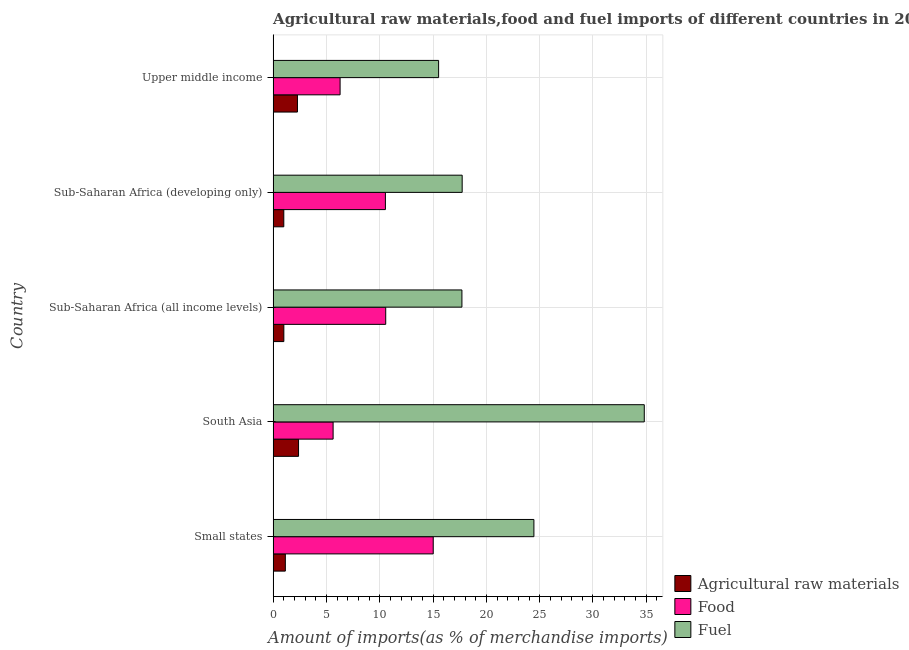Are the number of bars on each tick of the Y-axis equal?
Provide a succinct answer. Yes. How many bars are there on the 3rd tick from the bottom?
Provide a short and direct response. 3. What is the label of the 3rd group of bars from the top?
Offer a very short reply. Sub-Saharan Africa (all income levels). What is the percentage of fuel imports in Sub-Saharan Africa (developing only)?
Your response must be concise. 17.73. Across all countries, what is the maximum percentage of food imports?
Keep it short and to the point. 15.01. Across all countries, what is the minimum percentage of food imports?
Your response must be concise. 5.63. In which country was the percentage of raw materials imports minimum?
Provide a short and direct response. Sub-Saharan Africa (developing only). What is the total percentage of food imports in the graph?
Offer a terse response. 48.01. What is the difference between the percentage of food imports in South Asia and that in Sub-Saharan Africa (all income levels)?
Provide a succinct answer. -4.93. What is the difference between the percentage of fuel imports in Sub-Saharan Africa (developing only) and the percentage of raw materials imports in Upper middle income?
Make the answer very short. 15.45. What is the average percentage of raw materials imports per country?
Provide a short and direct response. 1.56. What is the difference between the percentage of food imports and percentage of raw materials imports in Sub-Saharan Africa (developing only)?
Ensure brevity in your answer.  9.53. In how many countries, is the percentage of fuel imports greater than 12 %?
Provide a succinct answer. 5. What is the ratio of the percentage of raw materials imports in Small states to that in Upper middle income?
Offer a very short reply. 0.5. Is the percentage of fuel imports in Sub-Saharan Africa (all income levels) less than that in Upper middle income?
Ensure brevity in your answer.  No. Is the difference between the percentage of food imports in Sub-Saharan Africa (developing only) and Upper middle income greater than the difference between the percentage of raw materials imports in Sub-Saharan Africa (developing only) and Upper middle income?
Make the answer very short. Yes. What is the difference between the highest and the second highest percentage of raw materials imports?
Offer a terse response. 0.1. What is the difference between the highest and the lowest percentage of fuel imports?
Your answer should be very brief. 19.29. In how many countries, is the percentage of raw materials imports greater than the average percentage of raw materials imports taken over all countries?
Keep it short and to the point. 2. What does the 3rd bar from the top in South Asia represents?
Give a very brief answer. Agricultural raw materials. What does the 1st bar from the bottom in South Asia represents?
Give a very brief answer. Agricultural raw materials. Is it the case that in every country, the sum of the percentage of raw materials imports and percentage of food imports is greater than the percentage of fuel imports?
Ensure brevity in your answer.  No. Are all the bars in the graph horizontal?
Give a very brief answer. Yes. What is the difference between two consecutive major ticks on the X-axis?
Offer a very short reply. 5. Are the values on the major ticks of X-axis written in scientific E-notation?
Your answer should be compact. No. Where does the legend appear in the graph?
Ensure brevity in your answer.  Bottom right. How many legend labels are there?
Offer a very short reply. 3. What is the title of the graph?
Your answer should be compact. Agricultural raw materials,food and fuel imports of different countries in 2008. What is the label or title of the X-axis?
Your answer should be very brief. Amount of imports(as % of merchandise imports). What is the label or title of the Y-axis?
Provide a short and direct response. Country. What is the Amount of imports(as % of merchandise imports) of Agricultural raw materials in Small states?
Your response must be concise. 1.15. What is the Amount of imports(as % of merchandise imports) of Food in Small states?
Offer a very short reply. 15.01. What is the Amount of imports(as % of merchandise imports) in Fuel in Small states?
Offer a terse response. 24.46. What is the Amount of imports(as % of merchandise imports) of Agricultural raw materials in South Asia?
Offer a terse response. 2.38. What is the Amount of imports(as % of merchandise imports) of Food in South Asia?
Offer a terse response. 5.63. What is the Amount of imports(as % of merchandise imports) in Fuel in South Asia?
Your response must be concise. 34.81. What is the Amount of imports(as % of merchandise imports) in Agricultural raw materials in Sub-Saharan Africa (all income levels)?
Ensure brevity in your answer.  1.01. What is the Amount of imports(as % of merchandise imports) in Food in Sub-Saharan Africa (all income levels)?
Give a very brief answer. 10.56. What is the Amount of imports(as % of merchandise imports) of Fuel in Sub-Saharan Africa (all income levels)?
Your answer should be compact. 17.71. What is the Amount of imports(as % of merchandise imports) in Agricultural raw materials in Sub-Saharan Africa (developing only)?
Provide a short and direct response. 1. What is the Amount of imports(as % of merchandise imports) of Food in Sub-Saharan Africa (developing only)?
Your answer should be compact. 10.53. What is the Amount of imports(as % of merchandise imports) in Fuel in Sub-Saharan Africa (developing only)?
Offer a terse response. 17.73. What is the Amount of imports(as % of merchandise imports) of Agricultural raw materials in Upper middle income?
Your response must be concise. 2.28. What is the Amount of imports(as % of merchandise imports) in Food in Upper middle income?
Ensure brevity in your answer.  6.28. What is the Amount of imports(as % of merchandise imports) of Fuel in Upper middle income?
Provide a succinct answer. 15.52. Across all countries, what is the maximum Amount of imports(as % of merchandise imports) of Agricultural raw materials?
Your response must be concise. 2.38. Across all countries, what is the maximum Amount of imports(as % of merchandise imports) of Food?
Keep it short and to the point. 15.01. Across all countries, what is the maximum Amount of imports(as % of merchandise imports) in Fuel?
Your answer should be very brief. 34.81. Across all countries, what is the minimum Amount of imports(as % of merchandise imports) of Agricultural raw materials?
Offer a very short reply. 1. Across all countries, what is the minimum Amount of imports(as % of merchandise imports) in Food?
Your response must be concise. 5.63. Across all countries, what is the minimum Amount of imports(as % of merchandise imports) of Fuel?
Your response must be concise. 15.52. What is the total Amount of imports(as % of merchandise imports) in Agricultural raw materials in the graph?
Your answer should be very brief. 7.82. What is the total Amount of imports(as % of merchandise imports) of Food in the graph?
Your answer should be compact. 48.01. What is the total Amount of imports(as % of merchandise imports) of Fuel in the graph?
Offer a very short reply. 110.23. What is the difference between the Amount of imports(as % of merchandise imports) in Agricultural raw materials in Small states and that in South Asia?
Ensure brevity in your answer.  -1.24. What is the difference between the Amount of imports(as % of merchandise imports) of Food in Small states and that in South Asia?
Make the answer very short. 9.39. What is the difference between the Amount of imports(as % of merchandise imports) in Fuel in Small states and that in South Asia?
Your answer should be very brief. -10.35. What is the difference between the Amount of imports(as % of merchandise imports) in Agricultural raw materials in Small states and that in Sub-Saharan Africa (all income levels)?
Give a very brief answer. 0.14. What is the difference between the Amount of imports(as % of merchandise imports) in Food in Small states and that in Sub-Saharan Africa (all income levels)?
Your answer should be very brief. 4.46. What is the difference between the Amount of imports(as % of merchandise imports) of Fuel in Small states and that in Sub-Saharan Africa (all income levels)?
Give a very brief answer. 6.75. What is the difference between the Amount of imports(as % of merchandise imports) in Agricultural raw materials in Small states and that in Sub-Saharan Africa (developing only)?
Ensure brevity in your answer.  0.14. What is the difference between the Amount of imports(as % of merchandise imports) of Food in Small states and that in Sub-Saharan Africa (developing only)?
Offer a very short reply. 4.48. What is the difference between the Amount of imports(as % of merchandise imports) of Fuel in Small states and that in Sub-Saharan Africa (developing only)?
Your answer should be compact. 6.73. What is the difference between the Amount of imports(as % of merchandise imports) in Agricultural raw materials in Small states and that in Upper middle income?
Give a very brief answer. -1.14. What is the difference between the Amount of imports(as % of merchandise imports) in Food in Small states and that in Upper middle income?
Provide a short and direct response. 8.73. What is the difference between the Amount of imports(as % of merchandise imports) in Fuel in Small states and that in Upper middle income?
Ensure brevity in your answer.  8.94. What is the difference between the Amount of imports(as % of merchandise imports) of Agricultural raw materials in South Asia and that in Sub-Saharan Africa (all income levels)?
Ensure brevity in your answer.  1.38. What is the difference between the Amount of imports(as % of merchandise imports) in Food in South Asia and that in Sub-Saharan Africa (all income levels)?
Offer a very short reply. -4.93. What is the difference between the Amount of imports(as % of merchandise imports) of Fuel in South Asia and that in Sub-Saharan Africa (all income levels)?
Make the answer very short. 17.1. What is the difference between the Amount of imports(as % of merchandise imports) in Agricultural raw materials in South Asia and that in Sub-Saharan Africa (developing only)?
Your answer should be very brief. 1.38. What is the difference between the Amount of imports(as % of merchandise imports) in Food in South Asia and that in Sub-Saharan Africa (developing only)?
Your answer should be compact. -4.9. What is the difference between the Amount of imports(as % of merchandise imports) of Fuel in South Asia and that in Sub-Saharan Africa (developing only)?
Give a very brief answer. 17.08. What is the difference between the Amount of imports(as % of merchandise imports) of Agricultural raw materials in South Asia and that in Upper middle income?
Provide a short and direct response. 0.1. What is the difference between the Amount of imports(as % of merchandise imports) in Food in South Asia and that in Upper middle income?
Your response must be concise. -0.65. What is the difference between the Amount of imports(as % of merchandise imports) in Fuel in South Asia and that in Upper middle income?
Make the answer very short. 19.29. What is the difference between the Amount of imports(as % of merchandise imports) of Agricultural raw materials in Sub-Saharan Africa (all income levels) and that in Sub-Saharan Africa (developing only)?
Your answer should be compact. 0. What is the difference between the Amount of imports(as % of merchandise imports) in Food in Sub-Saharan Africa (all income levels) and that in Sub-Saharan Africa (developing only)?
Your answer should be compact. 0.03. What is the difference between the Amount of imports(as % of merchandise imports) in Fuel in Sub-Saharan Africa (all income levels) and that in Sub-Saharan Africa (developing only)?
Give a very brief answer. -0.02. What is the difference between the Amount of imports(as % of merchandise imports) of Agricultural raw materials in Sub-Saharan Africa (all income levels) and that in Upper middle income?
Your response must be concise. -1.28. What is the difference between the Amount of imports(as % of merchandise imports) in Food in Sub-Saharan Africa (all income levels) and that in Upper middle income?
Your answer should be compact. 4.28. What is the difference between the Amount of imports(as % of merchandise imports) in Fuel in Sub-Saharan Africa (all income levels) and that in Upper middle income?
Keep it short and to the point. 2.19. What is the difference between the Amount of imports(as % of merchandise imports) in Agricultural raw materials in Sub-Saharan Africa (developing only) and that in Upper middle income?
Provide a short and direct response. -1.28. What is the difference between the Amount of imports(as % of merchandise imports) of Food in Sub-Saharan Africa (developing only) and that in Upper middle income?
Offer a very short reply. 4.25. What is the difference between the Amount of imports(as % of merchandise imports) in Fuel in Sub-Saharan Africa (developing only) and that in Upper middle income?
Offer a very short reply. 2.21. What is the difference between the Amount of imports(as % of merchandise imports) of Agricultural raw materials in Small states and the Amount of imports(as % of merchandise imports) of Food in South Asia?
Your response must be concise. -4.48. What is the difference between the Amount of imports(as % of merchandise imports) in Agricultural raw materials in Small states and the Amount of imports(as % of merchandise imports) in Fuel in South Asia?
Give a very brief answer. -33.66. What is the difference between the Amount of imports(as % of merchandise imports) of Food in Small states and the Amount of imports(as % of merchandise imports) of Fuel in South Asia?
Give a very brief answer. -19.8. What is the difference between the Amount of imports(as % of merchandise imports) in Agricultural raw materials in Small states and the Amount of imports(as % of merchandise imports) in Food in Sub-Saharan Africa (all income levels)?
Make the answer very short. -9.41. What is the difference between the Amount of imports(as % of merchandise imports) of Agricultural raw materials in Small states and the Amount of imports(as % of merchandise imports) of Fuel in Sub-Saharan Africa (all income levels)?
Make the answer very short. -16.56. What is the difference between the Amount of imports(as % of merchandise imports) in Food in Small states and the Amount of imports(as % of merchandise imports) in Fuel in Sub-Saharan Africa (all income levels)?
Provide a short and direct response. -2.69. What is the difference between the Amount of imports(as % of merchandise imports) of Agricultural raw materials in Small states and the Amount of imports(as % of merchandise imports) of Food in Sub-Saharan Africa (developing only)?
Give a very brief answer. -9.39. What is the difference between the Amount of imports(as % of merchandise imports) in Agricultural raw materials in Small states and the Amount of imports(as % of merchandise imports) in Fuel in Sub-Saharan Africa (developing only)?
Ensure brevity in your answer.  -16.59. What is the difference between the Amount of imports(as % of merchandise imports) in Food in Small states and the Amount of imports(as % of merchandise imports) in Fuel in Sub-Saharan Africa (developing only)?
Your response must be concise. -2.72. What is the difference between the Amount of imports(as % of merchandise imports) in Agricultural raw materials in Small states and the Amount of imports(as % of merchandise imports) in Food in Upper middle income?
Your answer should be very brief. -5.14. What is the difference between the Amount of imports(as % of merchandise imports) in Agricultural raw materials in Small states and the Amount of imports(as % of merchandise imports) in Fuel in Upper middle income?
Your response must be concise. -14.37. What is the difference between the Amount of imports(as % of merchandise imports) in Food in Small states and the Amount of imports(as % of merchandise imports) in Fuel in Upper middle income?
Your answer should be compact. -0.51. What is the difference between the Amount of imports(as % of merchandise imports) in Agricultural raw materials in South Asia and the Amount of imports(as % of merchandise imports) in Food in Sub-Saharan Africa (all income levels)?
Keep it short and to the point. -8.18. What is the difference between the Amount of imports(as % of merchandise imports) of Agricultural raw materials in South Asia and the Amount of imports(as % of merchandise imports) of Fuel in Sub-Saharan Africa (all income levels)?
Ensure brevity in your answer.  -15.32. What is the difference between the Amount of imports(as % of merchandise imports) of Food in South Asia and the Amount of imports(as % of merchandise imports) of Fuel in Sub-Saharan Africa (all income levels)?
Ensure brevity in your answer.  -12.08. What is the difference between the Amount of imports(as % of merchandise imports) of Agricultural raw materials in South Asia and the Amount of imports(as % of merchandise imports) of Food in Sub-Saharan Africa (developing only)?
Ensure brevity in your answer.  -8.15. What is the difference between the Amount of imports(as % of merchandise imports) in Agricultural raw materials in South Asia and the Amount of imports(as % of merchandise imports) in Fuel in Sub-Saharan Africa (developing only)?
Ensure brevity in your answer.  -15.35. What is the difference between the Amount of imports(as % of merchandise imports) of Food in South Asia and the Amount of imports(as % of merchandise imports) of Fuel in Sub-Saharan Africa (developing only)?
Offer a very short reply. -12.1. What is the difference between the Amount of imports(as % of merchandise imports) of Agricultural raw materials in South Asia and the Amount of imports(as % of merchandise imports) of Food in Upper middle income?
Ensure brevity in your answer.  -3.9. What is the difference between the Amount of imports(as % of merchandise imports) of Agricultural raw materials in South Asia and the Amount of imports(as % of merchandise imports) of Fuel in Upper middle income?
Your answer should be very brief. -13.14. What is the difference between the Amount of imports(as % of merchandise imports) in Food in South Asia and the Amount of imports(as % of merchandise imports) in Fuel in Upper middle income?
Keep it short and to the point. -9.89. What is the difference between the Amount of imports(as % of merchandise imports) of Agricultural raw materials in Sub-Saharan Africa (all income levels) and the Amount of imports(as % of merchandise imports) of Food in Sub-Saharan Africa (developing only)?
Your response must be concise. -9.53. What is the difference between the Amount of imports(as % of merchandise imports) in Agricultural raw materials in Sub-Saharan Africa (all income levels) and the Amount of imports(as % of merchandise imports) in Fuel in Sub-Saharan Africa (developing only)?
Ensure brevity in your answer.  -16.72. What is the difference between the Amount of imports(as % of merchandise imports) in Food in Sub-Saharan Africa (all income levels) and the Amount of imports(as % of merchandise imports) in Fuel in Sub-Saharan Africa (developing only)?
Your answer should be very brief. -7.17. What is the difference between the Amount of imports(as % of merchandise imports) in Agricultural raw materials in Sub-Saharan Africa (all income levels) and the Amount of imports(as % of merchandise imports) in Food in Upper middle income?
Make the answer very short. -5.28. What is the difference between the Amount of imports(as % of merchandise imports) of Agricultural raw materials in Sub-Saharan Africa (all income levels) and the Amount of imports(as % of merchandise imports) of Fuel in Upper middle income?
Keep it short and to the point. -14.51. What is the difference between the Amount of imports(as % of merchandise imports) in Food in Sub-Saharan Africa (all income levels) and the Amount of imports(as % of merchandise imports) in Fuel in Upper middle income?
Your response must be concise. -4.96. What is the difference between the Amount of imports(as % of merchandise imports) in Agricultural raw materials in Sub-Saharan Africa (developing only) and the Amount of imports(as % of merchandise imports) in Food in Upper middle income?
Make the answer very short. -5.28. What is the difference between the Amount of imports(as % of merchandise imports) of Agricultural raw materials in Sub-Saharan Africa (developing only) and the Amount of imports(as % of merchandise imports) of Fuel in Upper middle income?
Your answer should be very brief. -14.52. What is the difference between the Amount of imports(as % of merchandise imports) in Food in Sub-Saharan Africa (developing only) and the Amount of imports(as % of merchandise imports) in Fuel in Upper middle income?
Offer a very short reply. -4.99. What is the average Amount of imports(as % of merchandise imports) in Agricultural raw materials per country?
Keep it short and to the point. 1.56. What is the average Amount of imports(as % of merchandise imports) of Food per country?
Provide a short and direct response. 9.6. What is the average Amount of imports(as % of merchandise imports) of Fuel per country?
Make the answer very short. 22.05. What is the difference between the Amount of imports(as % of merchandise imports) in Agricultural raw materials and Amount of imports(as % of merchandise imports) in Food in Small states?
Offer a terse response. -13.87. What is the difference between the Amount of imports(as % of merchandise imports) in Agricultural raw materials and Amount of imports(as % of merchandise imports) in Fuel in Small states?
Give a very brief answer. -23.31. What is the difference between the Amount of imports(as % of merchandise imports) of Food and Amount of imports(as % of merchandise imports) of Fuel in Small states?
Give a very brief answer. -9.44. What is the difference between the Amount of imports(as % of merchandise imports) of Agricultural raw materials and Amount of imports(as % of merchandise imports) of Food in South Asia?
Keep it short and to the point. -3.24. What is the difference between the Amount of imports(as % of merchandise imports) of Agricultural raw materials and Amount of imports(as % of merchandise imports) of Fuel in South Asia?
Offer a terse response. -32.43. What is the difference between the Amount of imports(as % of merchandise imports) in Food and Amount of imports(as % of merchandise imports) in Fuel in South Asia?
Offer a terse response. -29.18. What is the difference between the Amount of imports(as % of merchandise imports) in Agricultural raw materials and Amount of imports(as % of merchandise imports) in Food in Sub-Saharan Africa (all income levels)?
Offer a very short reply. -9.55. What is the difference between the Amount of imports(as % of merchandise imports) in Agricultural raw materials and Amount of imports(as % of merchandise imports) in Fuel in Sub-Saharan Africa (all income levels)?
Your response must be concise. -16.7. What is the difference between the Amount of imports(as % of merchandise imports) in Food and Amount of imports(as % of merchandise imports) in Fuel in Sub-Saharan Africa (all income levels)?
Your response must be concise. -7.15. What is the difference between the Amount of imports(as % of merchandise imports) of Agricultural raw materials and Amount of imports(as % of merchandise imports) of Food in Sub-Saharan Africa (developing only)?
Ensure brevity in your answer.  -9.53. What is the difference between the Amount of imports(as % of merchandise imports) of Agricultural raw materials and Amount of imports(as % of merchandise imports) of Fuel in Sub-Saharan Africa (developing only)?
Make the answer very short. -16.73. What is the difference between the Amount of imports(as % of merchandise imports) in Food and Amount of imports(as % of merchandise imports) in Fuel in Sub-Saharan Africa (developing only)?
Provide a succinct answer. -7.2. What is the difference between the Amount of imports(as % of merchandise imports) in Agricultural raw materials and Amount of imports(as % of merchandise imports) in Food in Upper middle income?
Ensure brevity in your answer.  -4. What is the difference between the Amount of imports(as % of merchandise imports) of Agricultural raw materials and Amount of imports(as % of merchandise imports) of Fuel in Upper middle income?
Make the answer very short. -13.24. What is the difference between the Amount of imports(as % of merchandise imports) in Food and Amount of imports(as % of merchandise imports) in Fuel in Upper middle income?
Your response must be concise. -9.24. What is the ratio of the Amount of imports(as % of merchandise imports) in Agricultural raw materials in Small states to that in South Asia?
Provide a short and direct response. 0.48. What is the ratio of the Amount of imports(as % of merchandise imports) in Food in Small states to that in South Asia?
Provide a succinct answer. 2.67. What is the ratio of the Amount of imports(as % of merchandise imports) in Fuel in Small states to that in South Asia?
Offer a very short reply. 0.7. What is the ratio of the Amount of imports(as % of merchandise imports) of Agricultural raw materials in Small states to that in Sub-Saharan Africa (all income levels)?
Give a very brief answer. 1.14. What is the ratio of the Amount of imports(as % of merchandise imports) of Food in Small states to that in Sub-Saharan Africa (all income levels)?
Keep it short and to the point. 1.42. What is the ratio of the Amount of imports(as % of merchandise imports) in Fuel in Small states to that in Sub-Saharan Africa (all income levels)?
Make the answer very short. 1.38. What is the ratio of the Amount of imports(as % of merchandise imports) in Agricultural raw materials in Small states to that in Sub-Saharan Africa (developing only)?
Ensure brevity in your answer.  1.14. What is the ratio of the Amount of imports(as % of merchandise imports) in Food in Small states to that in Sub-Saharan Africa (developing only)?
Your answer should be compact. 1.43. What is the ratio of the Amount of imports(as % of merchandise imports) of Fuel in Small states to that in Sub-Saharan Africa (developing only)?
Offer a terse response. 1.38. What is the ratio of the Amount of imports(as % of merchandise imports) in Agricultural raw materials in Small states to that in Upper middle income?
Your answer should be very brief. 0.5. What is the ratio of the Amount of imports(as % of merchandise imports) of Food in Small states to that in Upper middle income?
Your answer should be compact. 2.39. What is the ratio of the Amount of imports(as % of merchandise imports) of Fuel in Small states to that in Upper middle income?
Provide a short and direct response. 1.58. What is the ratio of the Amount of imports(as % of merchandise imports) of Agricultural raw materials in South Asia to that in Sub-Saharan Africa (all income levels)?
Give a very brief answer. 2.37. What is the ratio of the Amount of imports(as % of merchandise imports) in Food in South Asia to that in Sub-Saharan Africa (all income levels)?
Ensure brevity in your answer.  0.53. What is the ratio of the Amount of imports(as % of merchandise imports) of Fuel in South Asia to that in Sub-Saharan Africa (all income levels)?
Your answer should be very brief. 1.97. What is the ratio of the Amount of imports(as % of merchandise imports) in Agricultural raw materials in South Asia to that in Sub-Saharan Africa (developing only)?
Give a very brief answer. 2.38. What is the ratio of the Amount of imports(as % of merchandise imports) of Food in South Asia to that in Sub-Saharan Africa (developing only)?
Make the answer very short. 0.53. What is the ratio of the Amount of imports(as % of merchandise imports) in Fuel in South Asia to that in Sub-Saharan Africa (developing only)?
Offer a very short reply. 1.96. What is the ratio of the Amount of imports(as % of merchandise imports) of Agricultural raw materials in South Asia to that in Upper middle income?
Provide a succinct answer. 1.05. What is the ratio of the Amount of imports(as % of merchandise imports) in Food in South Asia to that in Upper middle income?
Provide a short and direct response. 0.9. What is the ratio of the Amount of imports(as % of merchandise imports) in Fuel in South Asia to that in Upper middle income?
Offer a very short reply. 2.24. What is the ratio of the Amount of imports(as % of merchandise imports) in Fuel in Sub-Saharan Africa (all income levels) to that in Sub-Saharan Africa (developing only)?
Offer a terse response. 1. What is the ratio of the Amount of imports(as % of merchandise imports) of Agricultural raw materials in Sub-Saharan Africa (all income levels) to that in Upper middle income?
Keep it short and to the point. 0.44. What is the ratio of the Amount of imports(as % of merchandise imports) in Food in Sub-Saharan Africa (all income levels) to that in Upper middle income?
Give a very brief answer. 1.68. What is the ratio of the Amount of imports(as % of merchandise imports) in Fuel in Sub-Saharan Africa (all income levels) to that in Upper middle income?
Your answer should be compact. 1.14. What is the ratio of the Amount of imports(as % of merchandise imports) of Agricultural raw materials in Sub-Saharan Africa (developing only) to that in Upper middle income?
Make the answer very short. 0.44. What is the ratio of the Amount of imports(as % of merchandise imports) of Food in Sub-Saharan Africa (developing only) to that in Upper middle income?
Your answer should be compact. 1.68. What is the ratio of the Amount of imports(as % of merchandise imports) in Fuel in Sub-Saharan Africa (developing only) to that in Upper middle income?
Your answer should be very brief. 1.14. What is the difference between the highest and the second highest Amount of imports(as % of merchandise imports) of Agricultural raw materials?
Offer a terse response. 0.1. What is the difference between the highest and the second highest Amount of imports(as % of merchandise imports) in Food?
Make the answer very short. 4.46. What is the difference between the highest and the second highest Amount of imports(as % of merchandise imports) of Fuel?
Make the answer very short. 10.35. What is the difference between the highest and the lowest Amount of imports(as % of merchandise imports) in Agricultural raw materials?
Provide a short and direct response. 1.38. What is the difference between the highest and the lowest Amount of imports(as % of merchandise imports) in Food?
Offer a very short reply. 9.39. What is the difference between the highest and the lowest Amount of imports(as % of merchandise imports) in Fuel?
Give a very brief answer. 19.29. 